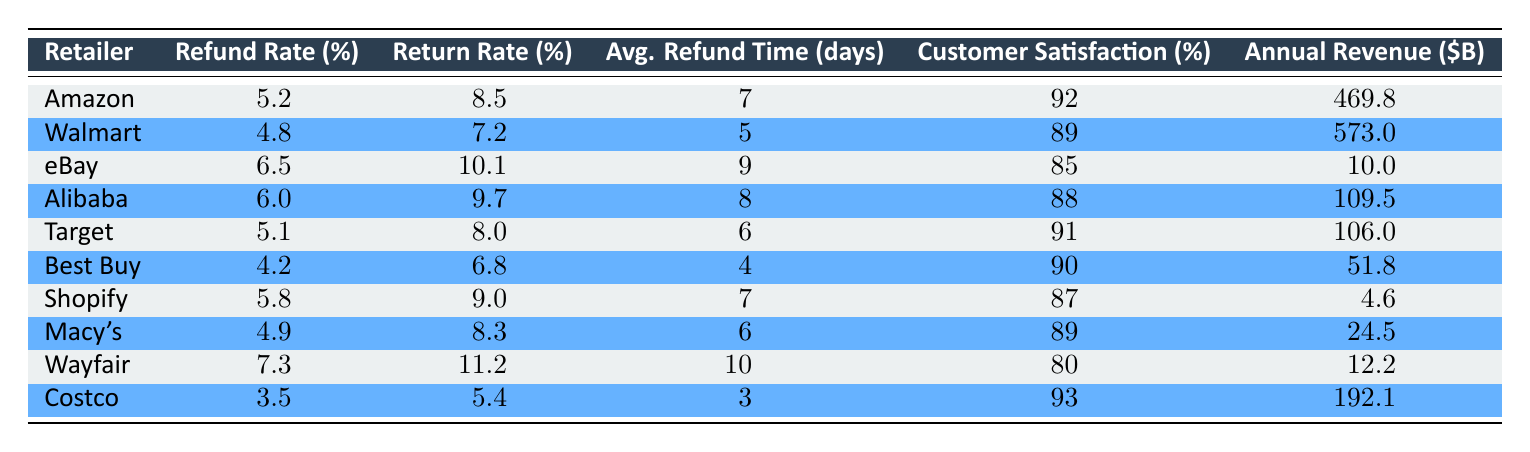What is the refund rate for Walmart? The table shows a specific value for Walmart's refund rate in the third column. The value is listed as 4.8%.
Answer: 4.8% Which retailer has the highest return rate? By observing the return rate column, Wayfair has the highest return rate at 11.2%, compared to others listed.
Answer: Wayfair What is the average refund time across all retailers? To find the average refund time, add the average refund times together (7 + 5 + 9 + 8 + 6 + 4 + 7 + 6 + 10 + 3 = 65 days) and divide by the number of retailers (10). Therefore, the average refund time is 65/10 = 6.5 days.
Answer: 6.5 days Does Costco have the lowest refund rate? By comparing the refund rates in the table, Costco's refund rate is 3.5%, which is lower than all other retailers listed.
Answer: Yes Is there a correlation between customer satisfaction and refund rate? To assess the correlation, we can note that higher customer satisfaction percentages (like Costco at 93% with a low refund rate of 3.5%) often align with lower refund rates, while some retailers with higher refund rates (like Wayfair at 7.3% with an 80% satisfaction rate) show lower satisfaction. However, more rigorous statistical analysis would be needed to establish true correlation. Based on the table alone, we see varying results.
Answer: No direct correlation evident 